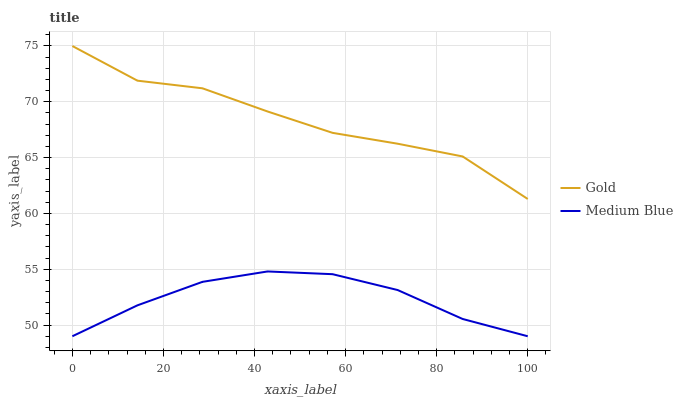Does Gold have the minimum area under the curve?
Answer yes or no. No. Is Gold the smoothest?
Answer yes or no. No. Does Gold have the lowest value?
Answer yes or no. No. Is Medium Blue less than Gold?
Answer yes or no. Yes. Is Gold greater than Medium Blue?
Answer yes or no. Yes. Does Medium Blue intersect Gold?
Answer yes or no. No. 